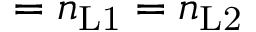Convert formula to latex. <formula><loc_0><loc_0><loc_500><loc_500>= n _ { L 1 } = n _ { L 2 }</formula> 